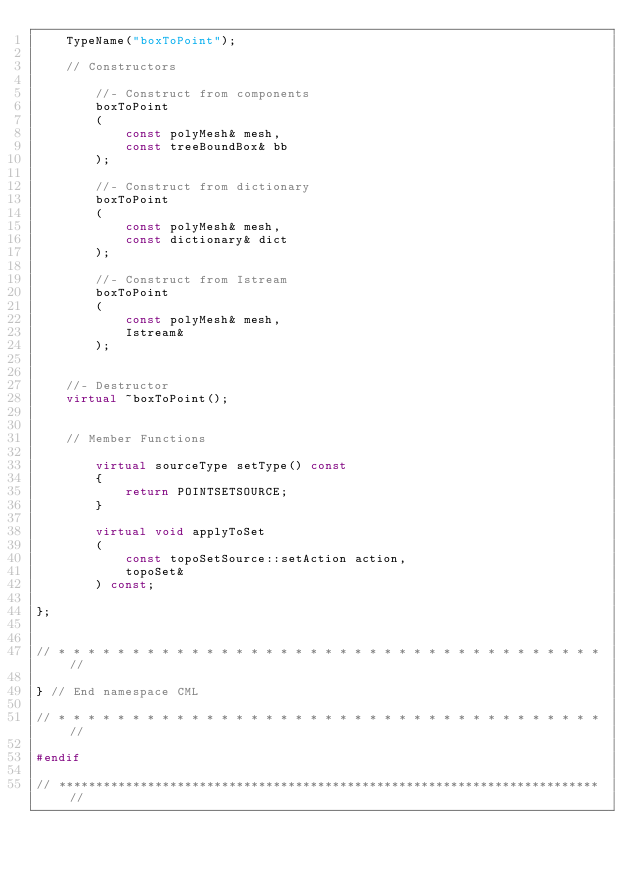Convert code to text. <code><loc_0><loc_0><loc_500><loc_500><_C++_>    TypeName("boxToPoint");

    // Constructors

        //- Construct from components
        boxToPoint
        (
            const polyMesh& mesh,
            const treeBoundBox& bb
        );

        //- Construct from dictionary
        boxToPoint
        (
            const polyMesh& mesh,
            const dictionary& dict
        );

        //- Construct from Istream
        boxToPoint
        (
            const polyMesh& mesh,
            Istream&
        );


    //- Destructor
    virtual ~boxToPoint();


    // Member Functions

        virtual sourceType setType() const
        {
            return POINTSETSOURCE;
        }

        virtual void applyToSet
        (
            const topoSetSource::setAction action,
            topoSet&
        ) const;

};


// * * * * * * * * * * * * * * * * * * * * * * * * * * * * * * * * * * * * * //

} // End namespace CML

// * * * * * * * * * * * * * * * * * * * * * * * * * * * * * * * * * * * * * //

#endif

// ************************************************************************* //
</code> 